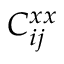Convert formula to latex. <formula><loc_0><loc_0><loc_500><loc_500>C _ { i j } ^ { x x }</formula> 